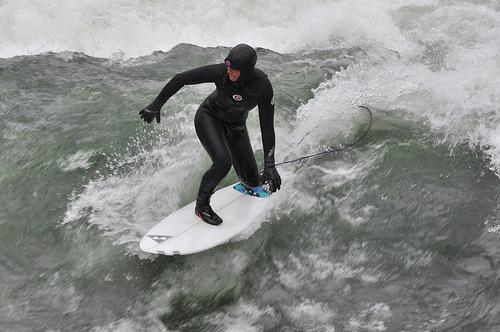Provide a brief description of the person in the context of a product advertisement. Meet our adept surfer, balancing effortlessly with arms raised, enjoying the thrill of the ocean on our premium white surfboard. Describe the range of surf conditions in the image, focusing on the waves. Diverse white and gray ocean waves varying in size and positions - from small, distant ones to large, crashing waves near and around the surfer. Select the activity and focus of the person in the image. Surfing on a white surfboard with concentration on maintaining balance. What position is the person in the image taking while surfing? Person is standing upright with arms raised for balance. In a VQA-style question, identify the color and number of fins on the surfboard. The surfboard has three blue fins. Explain the purpose of the rope in the image. The rope of the surfboard serves as a leash, keeping the board connected to the surfer for greater control and safety during surfing. Imagine you are advertising this surfboard, describe the person using it and the performance. Ride the waves with our sturdy, white surfboard, taking you to new heights just like the agile surfer with raised arms, long hair, and focused expression in our image. Explain the location and condition of the ocean where the person is surfing. The ocean has white and gray waves crashing, creating foam, both near and far from the surfer. They are amidst an active and exhilarating aquatic environment. As a visual entailment task, what is the broader context of this image? A person enjoying an adventurous water sport in a lively ocean setting with various waves and surf conditions. 